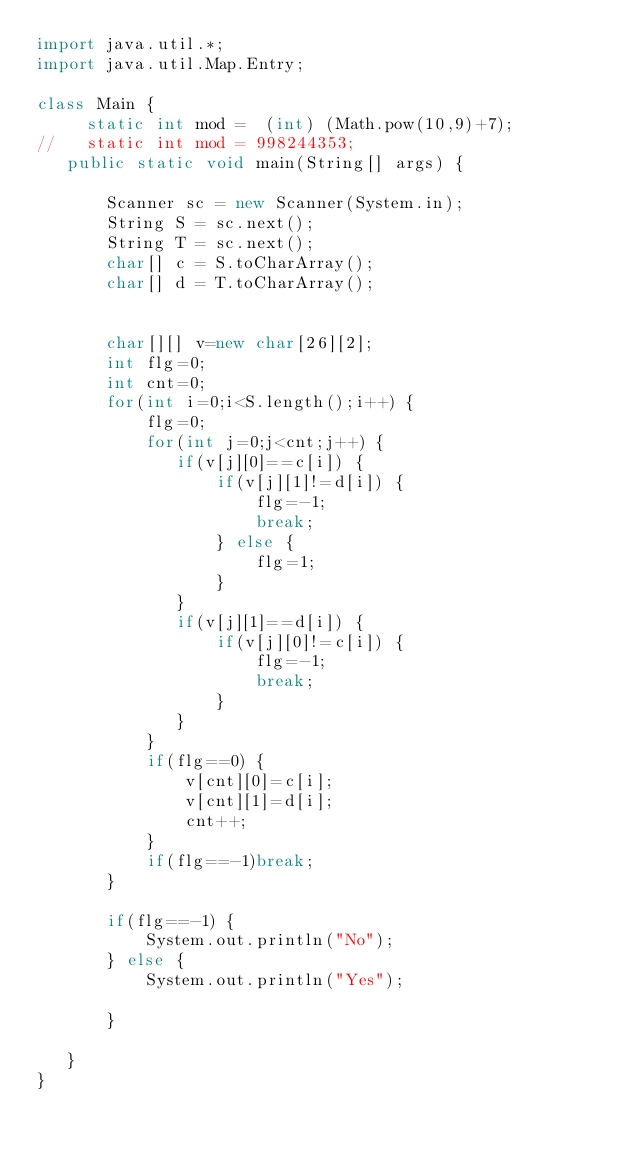<code> <loc_0><loc_0><loc_500><loc_500><_Java_>import java.util.*;
import java.util.Map.Entry;
 
class Main {
	 static int mod =  (int) (Math.pow(10,9)+7);
//	 static int mod = 998244353;
   public static void main(String[] args) {
	   
       Scanner sc = new Scanner(System.in);
       String S = sc.next();
       String T = sc.next();
       char[] c = S.toCharArray();
       char[] d = T.toCharArray();
       
       
       char[][] v=new char[26][2];
       int flg=0;
       int cnt=0;
       for(int i=0;i<S.length();i++) {
    	   flg=0;
    	   for(int j=0;j<cnt;j++) {
     		  if(v[j][0]==c[i]) {
    			  if(v[j][1]!=d[i]) {
    				  flg=-1;
    				  break;
    			  } else {
    				  flg=1;
    			  }
    		  }
    		  if(v[j][1]==d[i]) {
    			  if(v[j][0]!=c[i]) {
    				  flg=-1;
    				  break;
    			  }
    		  }    		  
    	   }
    	   if(flg==0) {
    		   v[cnt][0]=c[i];
    		   v[cnt][1]=d[i];
    		   cnt++;
    	   }
    	   if(flg==-1)break;
       }
       
       if(flg==-1) {
    	   System.out.println("No");
       } else {
    	   System.out.println("Yes");

       }
       
   }
}</code> 